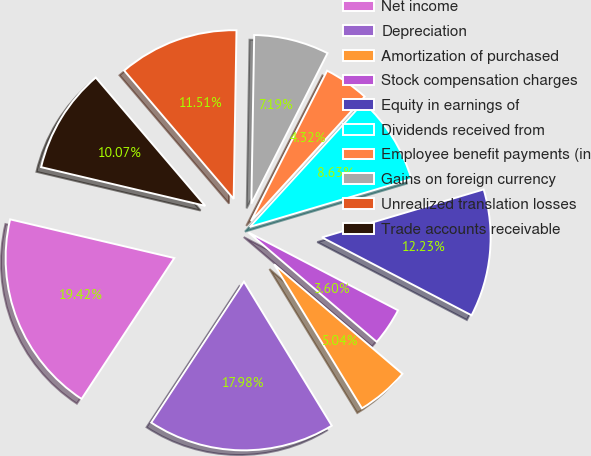Convert chart. <chart><loc_0><loc_0><loc_500><loc_500><pie_chart><fcel>Net income<fcel>Depreciation<fcel>Amortization of purchased<fcel>Stock compensation charges<fcel>Equity in earnings of<fcel>Dividends received from<fcel>Employee benefit payments (in<fcel>Gains on foreign currency<fcel>Unrealized translation losses<fcel>Trade accounts receivable<nl><fcel>19.42%<fcel>17.98%<fcel>5.04%<fcel>3.6%<fcel>12.23%<fcel>8.63%<fcel>4.32%<fcel>7.19%<fcel>11.51%<fcel>10.07%<nl></chart> 